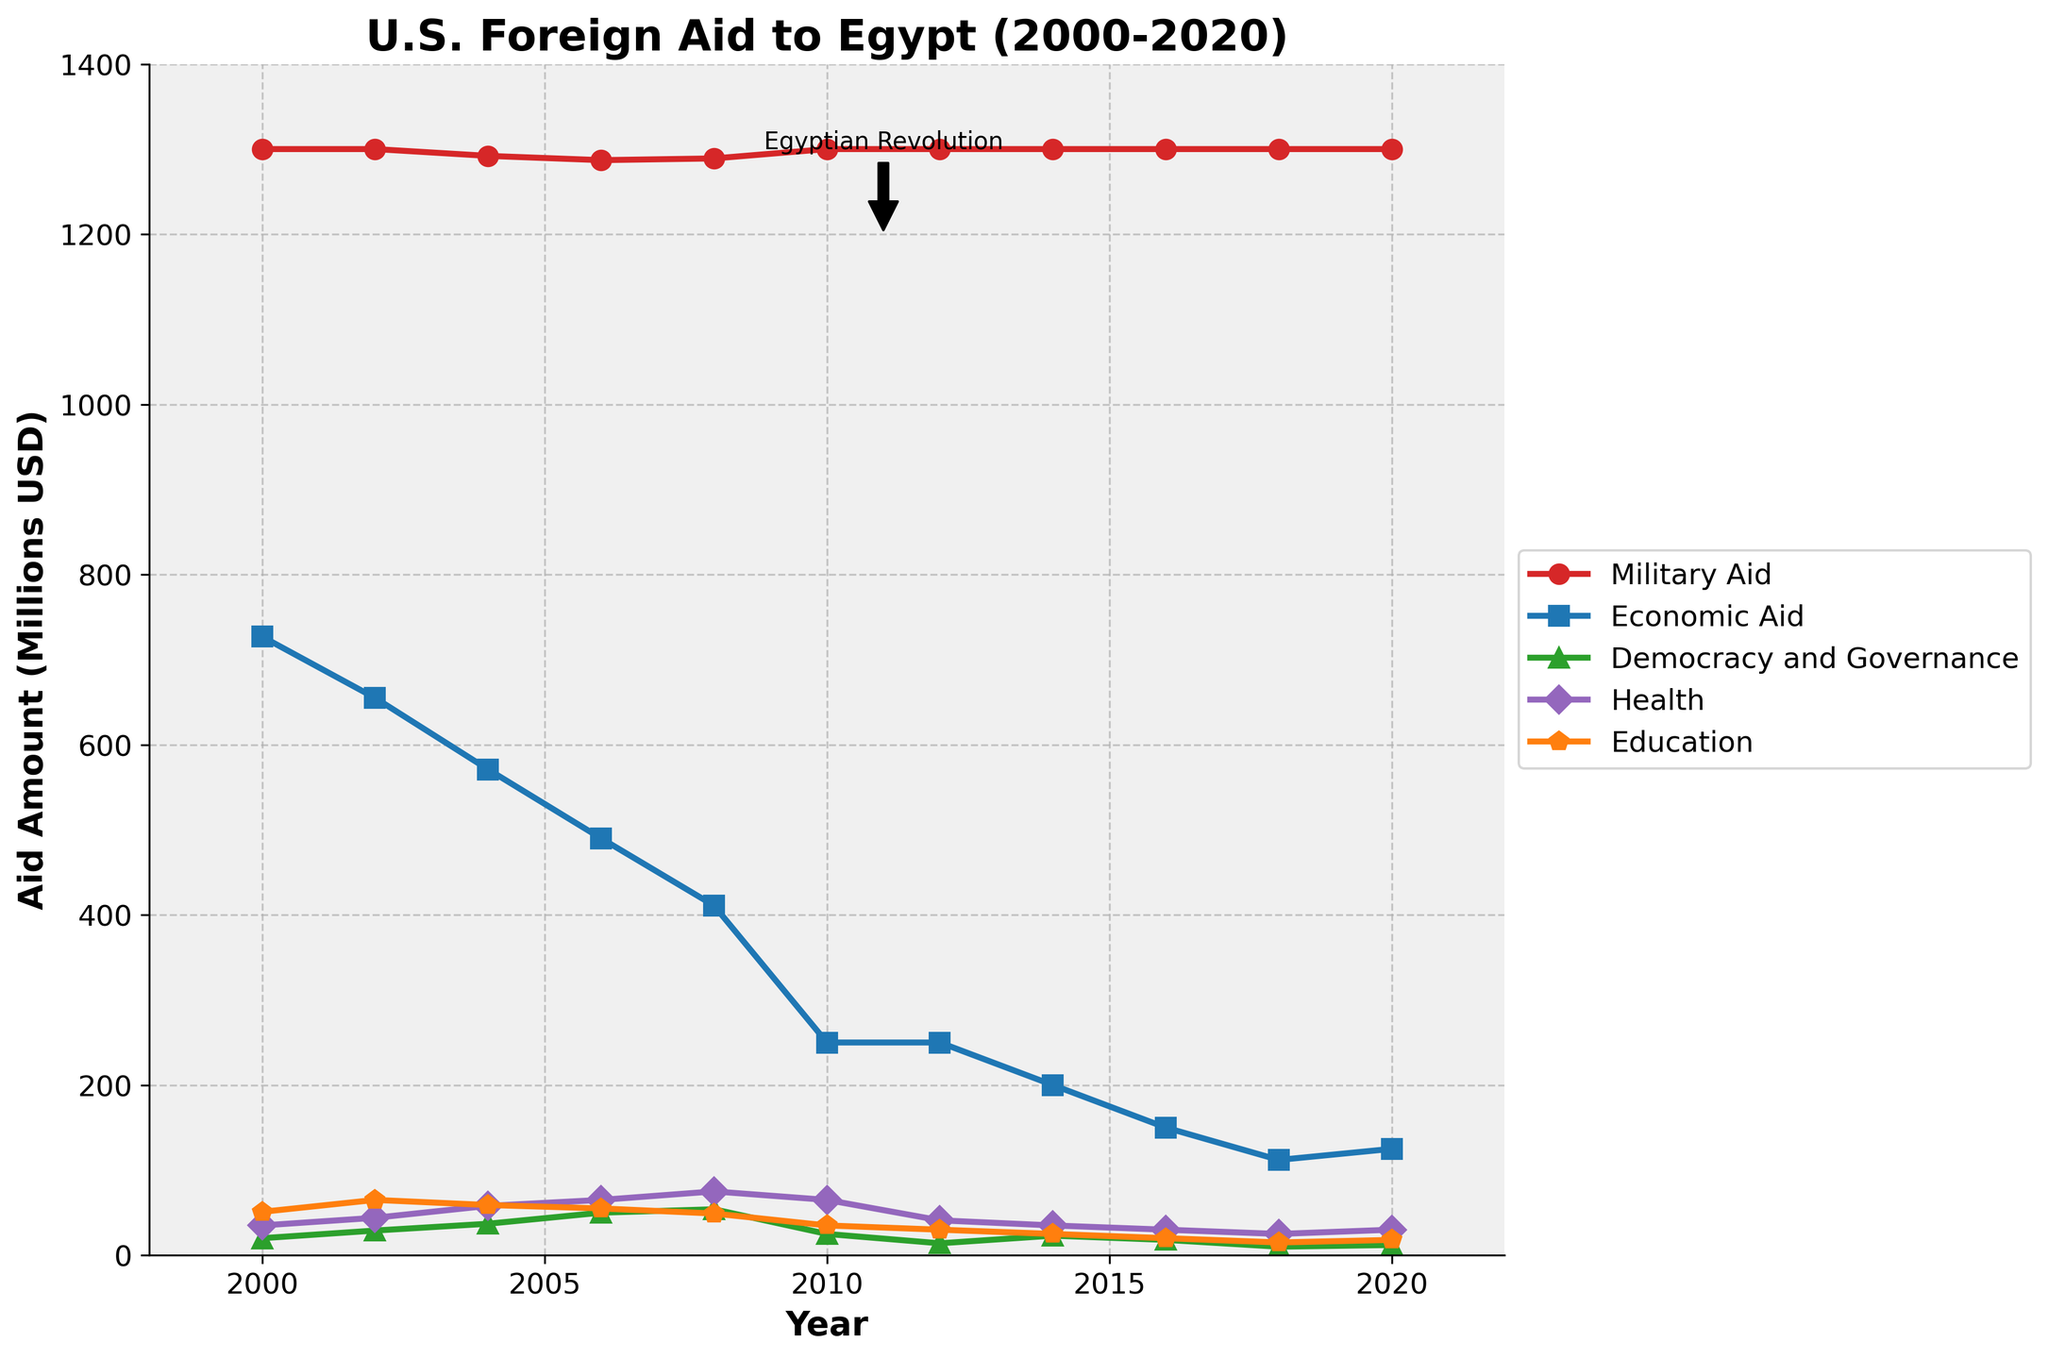What trend can you observe in Military Aid from 2000 to 2020? Observing the Military Aid line in the figure, it remains relatively constant over the entire period from 2000 to 2020.
Answer: Relatively constant How does Economic Aid change from 2000 to 2020? Examining the Economic Aid line, it shows a decreasing trend from about 727 million USD in 2000 down to 125 million USD in 2020.
Answer: Decreasing In which year did Democracy and Governance aid receive the highest funding amount and what was it? By looking at the peaks in the Democracy and Governance aid line, the highest point is in 2008 with about 54 million USD.
Answer: 2008, 54 million USD Which sector had the steepest decline in aid from 2000 to 2020? Comparing the slopes of the lines from 2000 to 2020, Economic Aid shows the steepest decline, going from 727 million USD to 125 million USD.
Answer: Economic Aid What happens to Health sector aid before and after the Egyptian Revolution? Observing the point of annotation for the Egyptian Revolution in 2011, there is a noticeable drop from 65 million USD in 2010 to 41 million USD in 2012.
Answer: Drops from 65 to 41 million USD How does the amount of Military Aid compare to Economic Aid in 2020? Checking the figure for both Military and Economic Aid lines at the year 2020, Military Aid is 1300 million USD and Economic Aid is 125 million USD.
Answer: Military Aid is much higher By how much did Education aid decrease from 2000 to 2020? Examining the Education aid line, it decreases from 51 million USD in 2000 to 18 million USD in 2020. The difference is 51 - 18 = 33 million USD.
Answer: 33 million USD Which sector received the least aid consistently in each year? Analyzing all lines’ positions, Democracy and Governance aid consistently appears at the bottom compared to other sectors.
Answer: Democracy and Governance What was the overall trend in total foreign aid from the U.S. to Egypt from 2000 to 2020? Summarizing the trends of all lines, the overall amount of aid is decreasing, with individual lines for various sectors generally showing a decline.
Answer: Decreasing What can be inferred about the focus of U.S. aid to Egypt over the years 2000-2020? Observing the dominance of the Military Aid line remaining constant while other sectors' aid decreases, the focus seems more on military aid.
Answer: Focus on military aid 